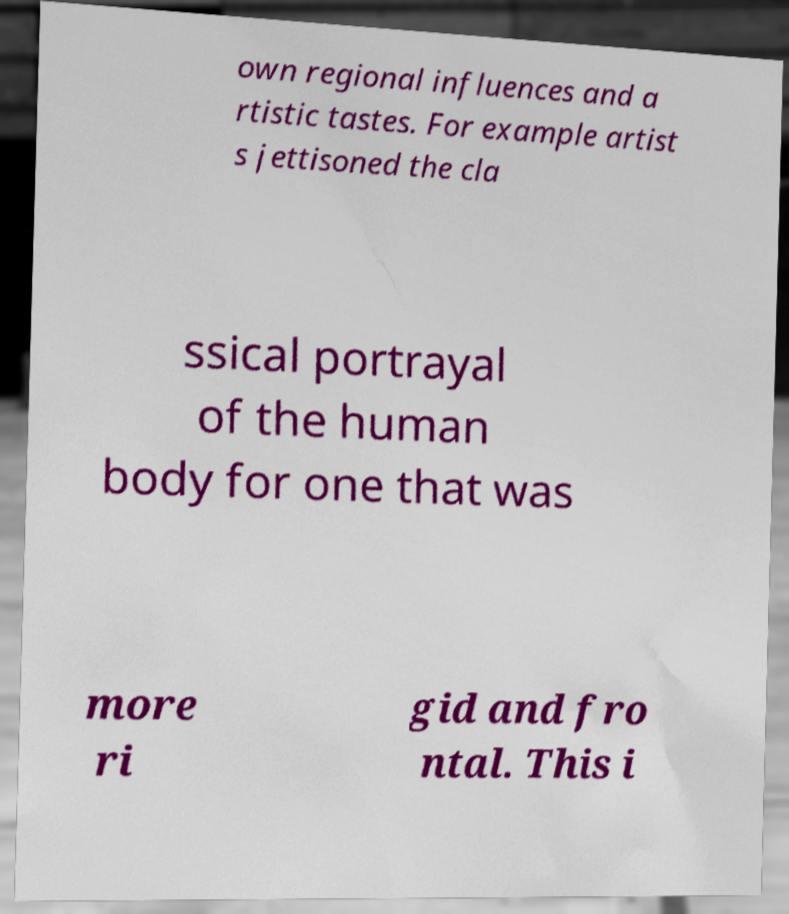Can you accurately transcribe the text from the provided image for me? own regional influences and a rtistic tastes. For example artist s jettisoned the cla ssical portrayal of the human body for one that was more ri gid and fro ntal. This i 